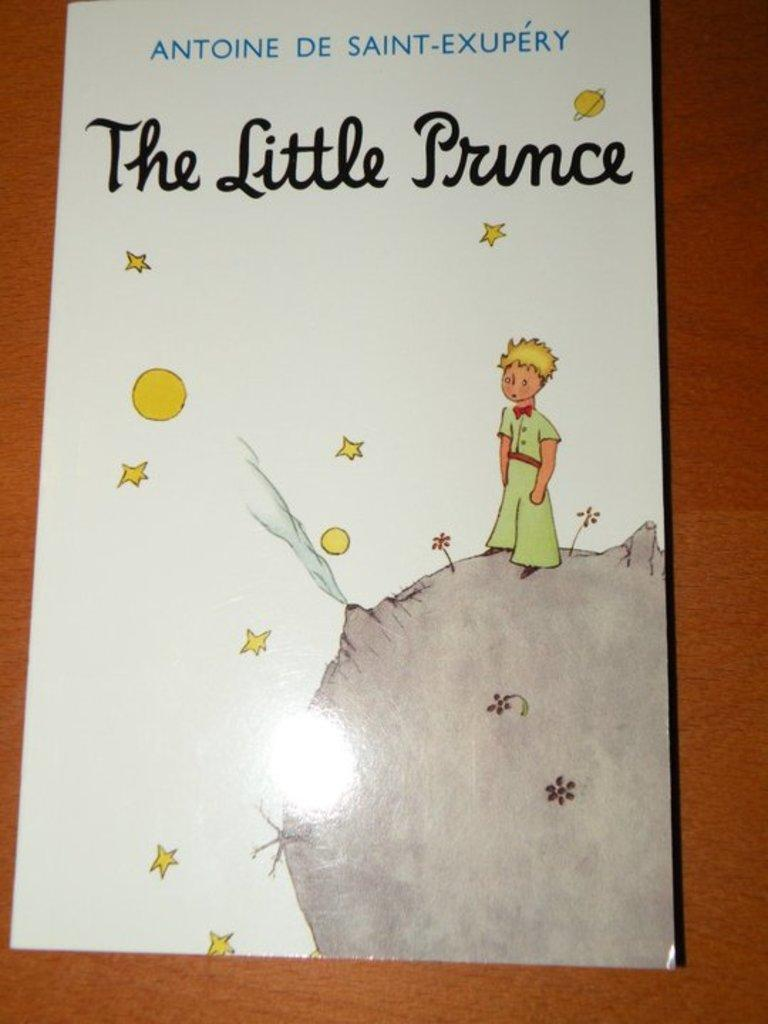<image>
Summarize the visual content of the image. a cover of the book The Little Prince 